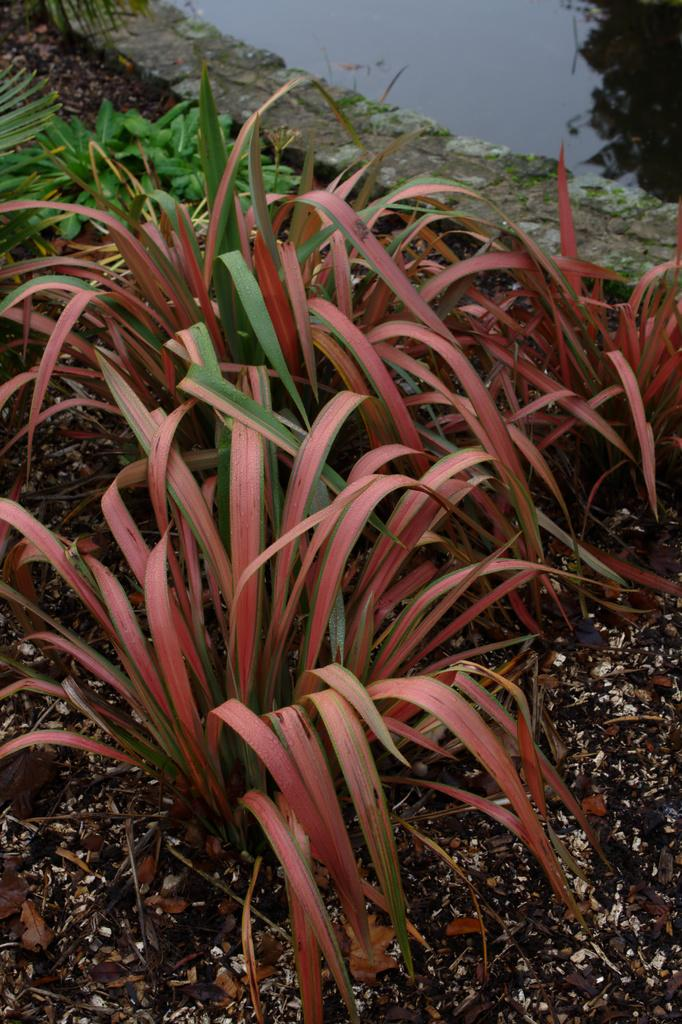What is located in the middle of the image? There are plants in the middle of the image. What can be seen in the top right hand side of the image? There is water visible in the top right hand side of the image. How much debt is the potato carrying in the image? There is no potato or mention of debt in the image. 